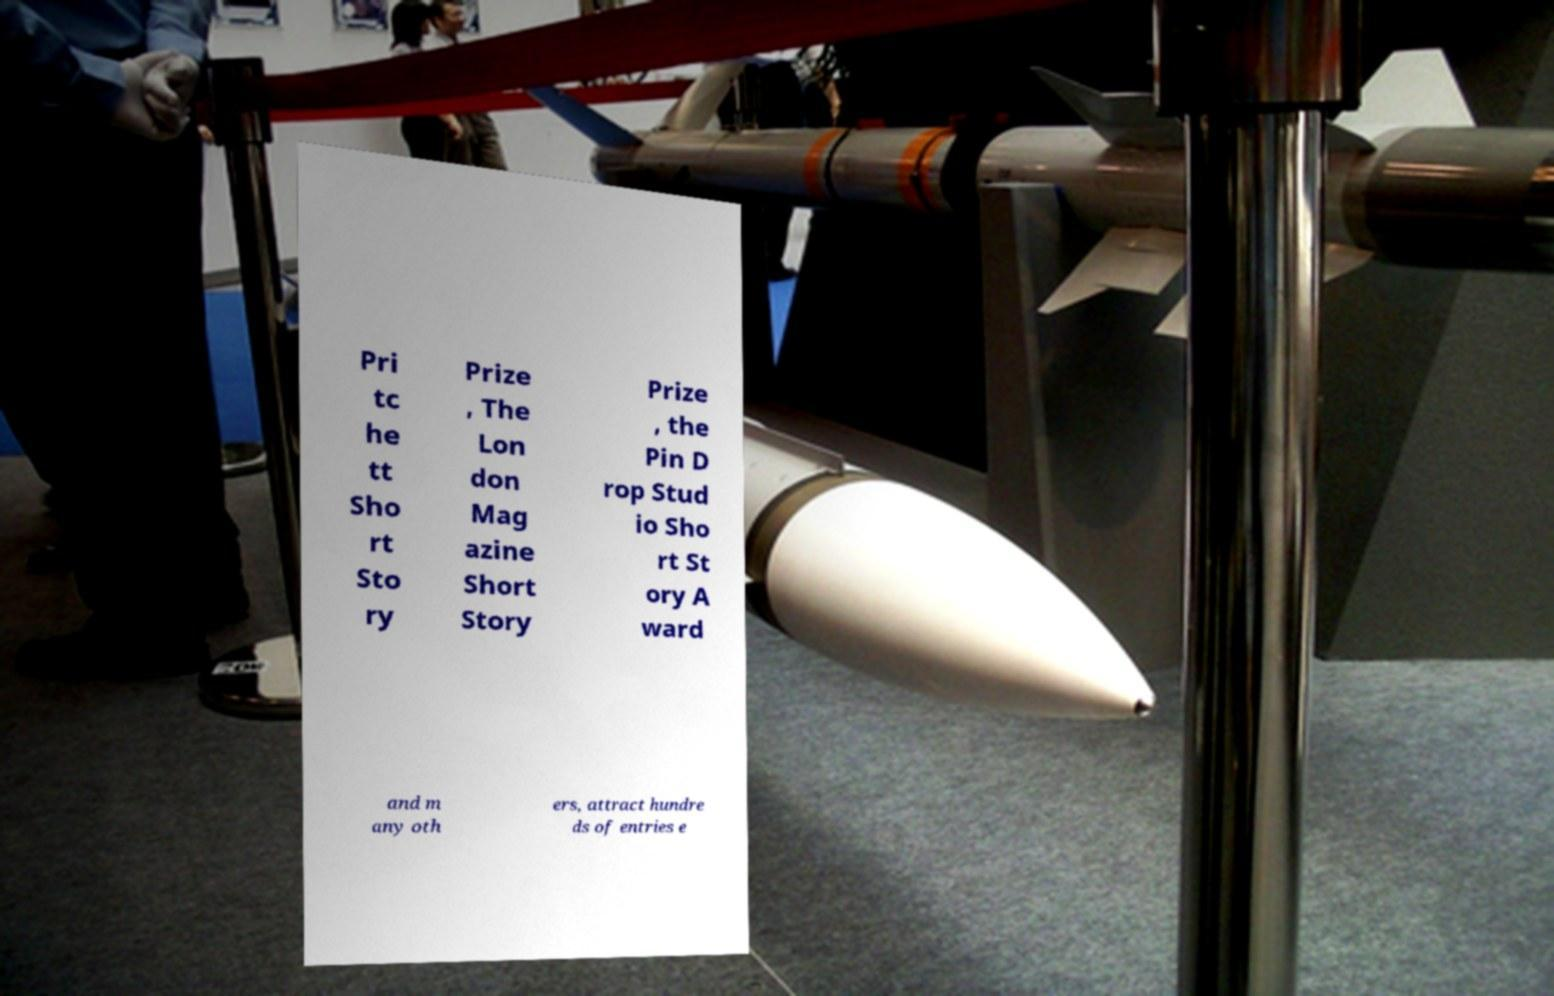Please identify and transcribe the text found in this image. Pri tc he tt Sho rt Sto ry Prize , The Lon don Mag azine Short Story Prize , the Pin D rop Stud io Sho rt St ory A ward and m any oth ers, attract hundre ds of entries e 